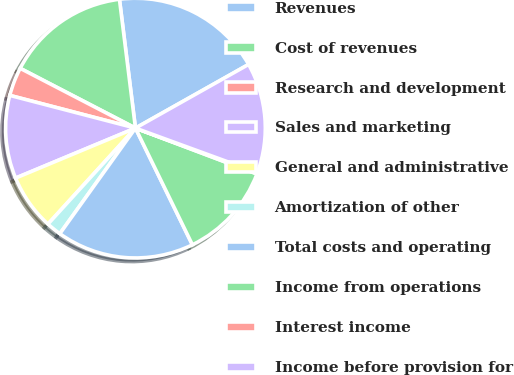Convert chart. <chart><loc_0><loc_0><loc_500><loc_500><pie_chart><fcel>Revenues<fcel>Cost of revenues<fcel>Research and development<fcel>Sales and marketing<fcel>General and administrative<fcel>Amortization of other<fcel>Total costs and operating<fcel>Income from operations<fcel>Interest income<fcel>Income before provision for<nl><fcel>18.81%<fcel>15.42%<fcel>3.56%<fcel>10.34%<fcel>6.95%<fcel>1.87%<fcel>17.12%<fcel>12.03%<fcel>0.17%<fcel>13.73%<nl></chart> 